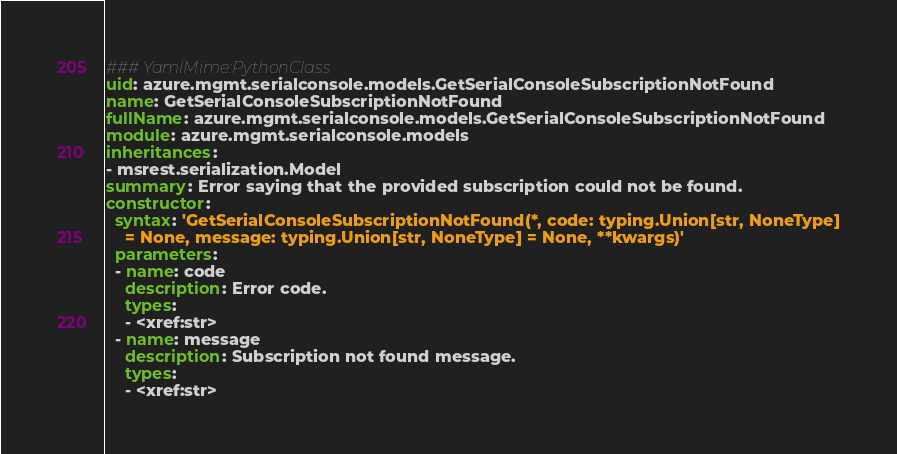Convert code to text. <code><loc_0><loc_0><loc_500><loc_500><_YAML_>### YamlMime:PythonClass
uid: azure.mgmt.serialconsole.models.GetSerialConsoleSubscriptionNotFound
name: GetSerialConsoleSubscriptionNotFound
fullName: azure.mgmt.serialconsole.models.GetSerialConsoleSubscriptionNotFound
module: azure.mgmt.serialconsole.models
inheritances:
- msrest.serialization.Model
summary: Error saying that the provided subscription could not be found.
constructor:
  syntax: 'GetSerialConsoleSubscriptionNotFound(*, code: typing.Union[str, NoneType]
    = None, message: typing.Union[str, NoneType] = None, **kwargs)'
  parameters:
  - name: code
    description: Error code.
    types:
    - <xref:str>
  - name: message
    description: Subscription not found message.
    types:
    - <xref:str>
</code> 